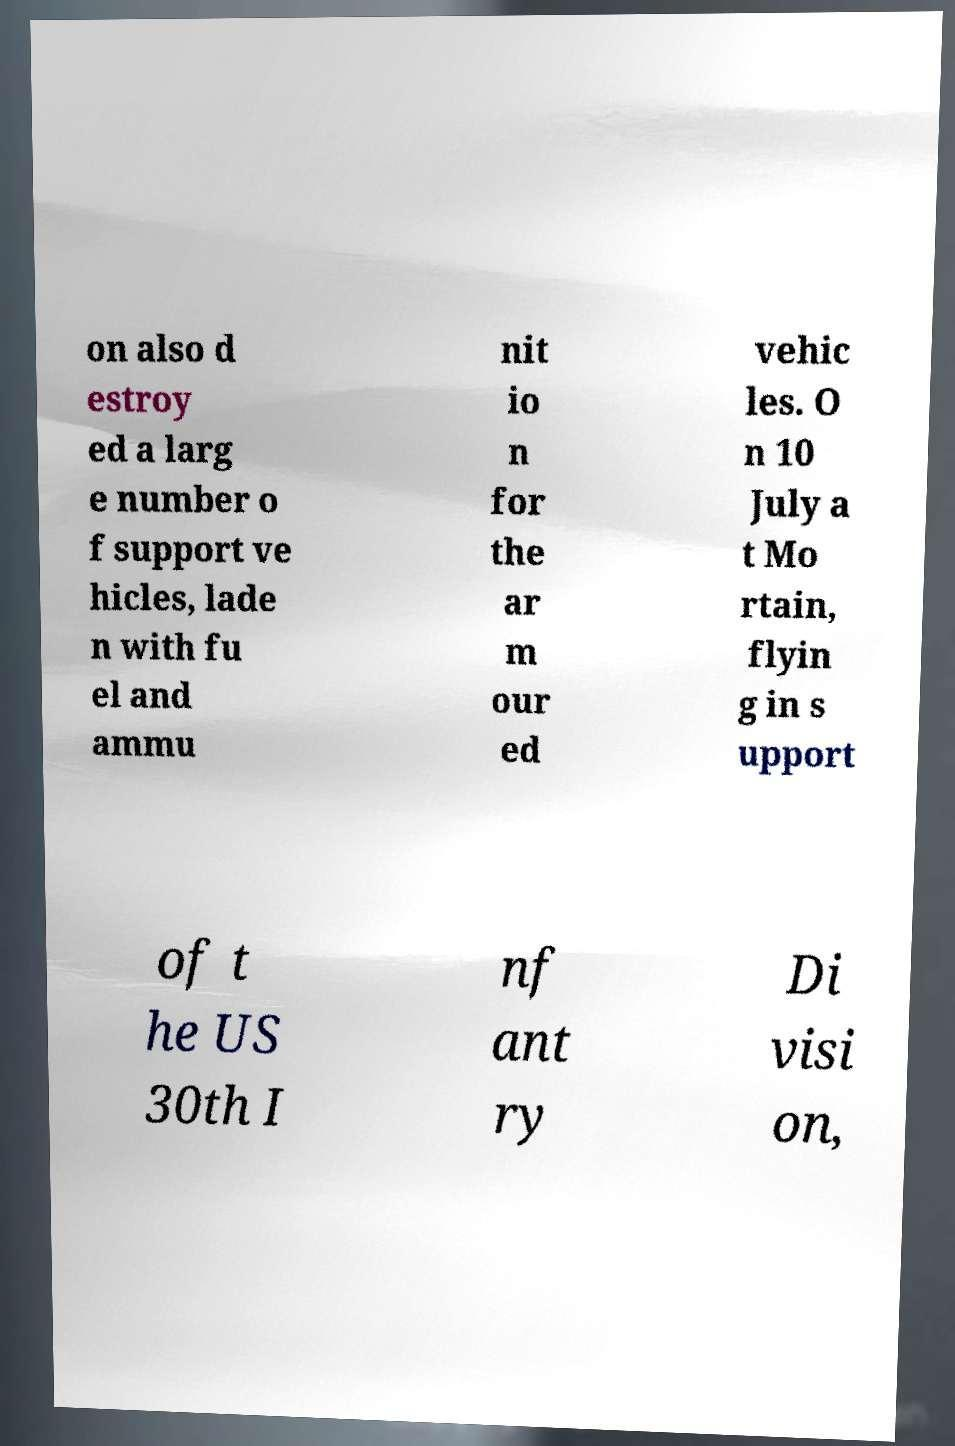What messages or text are displayed in this image? I need them in a readable, typed format. on also d estroy ed a larg e number o f support ve hicles, lade n with fu el and ammu nit io n for the ar m our ed vehic les. O n 10 July a t Mo rtain, flyin g in s upport of t he US 30th I nf ant ry Di visi on, 